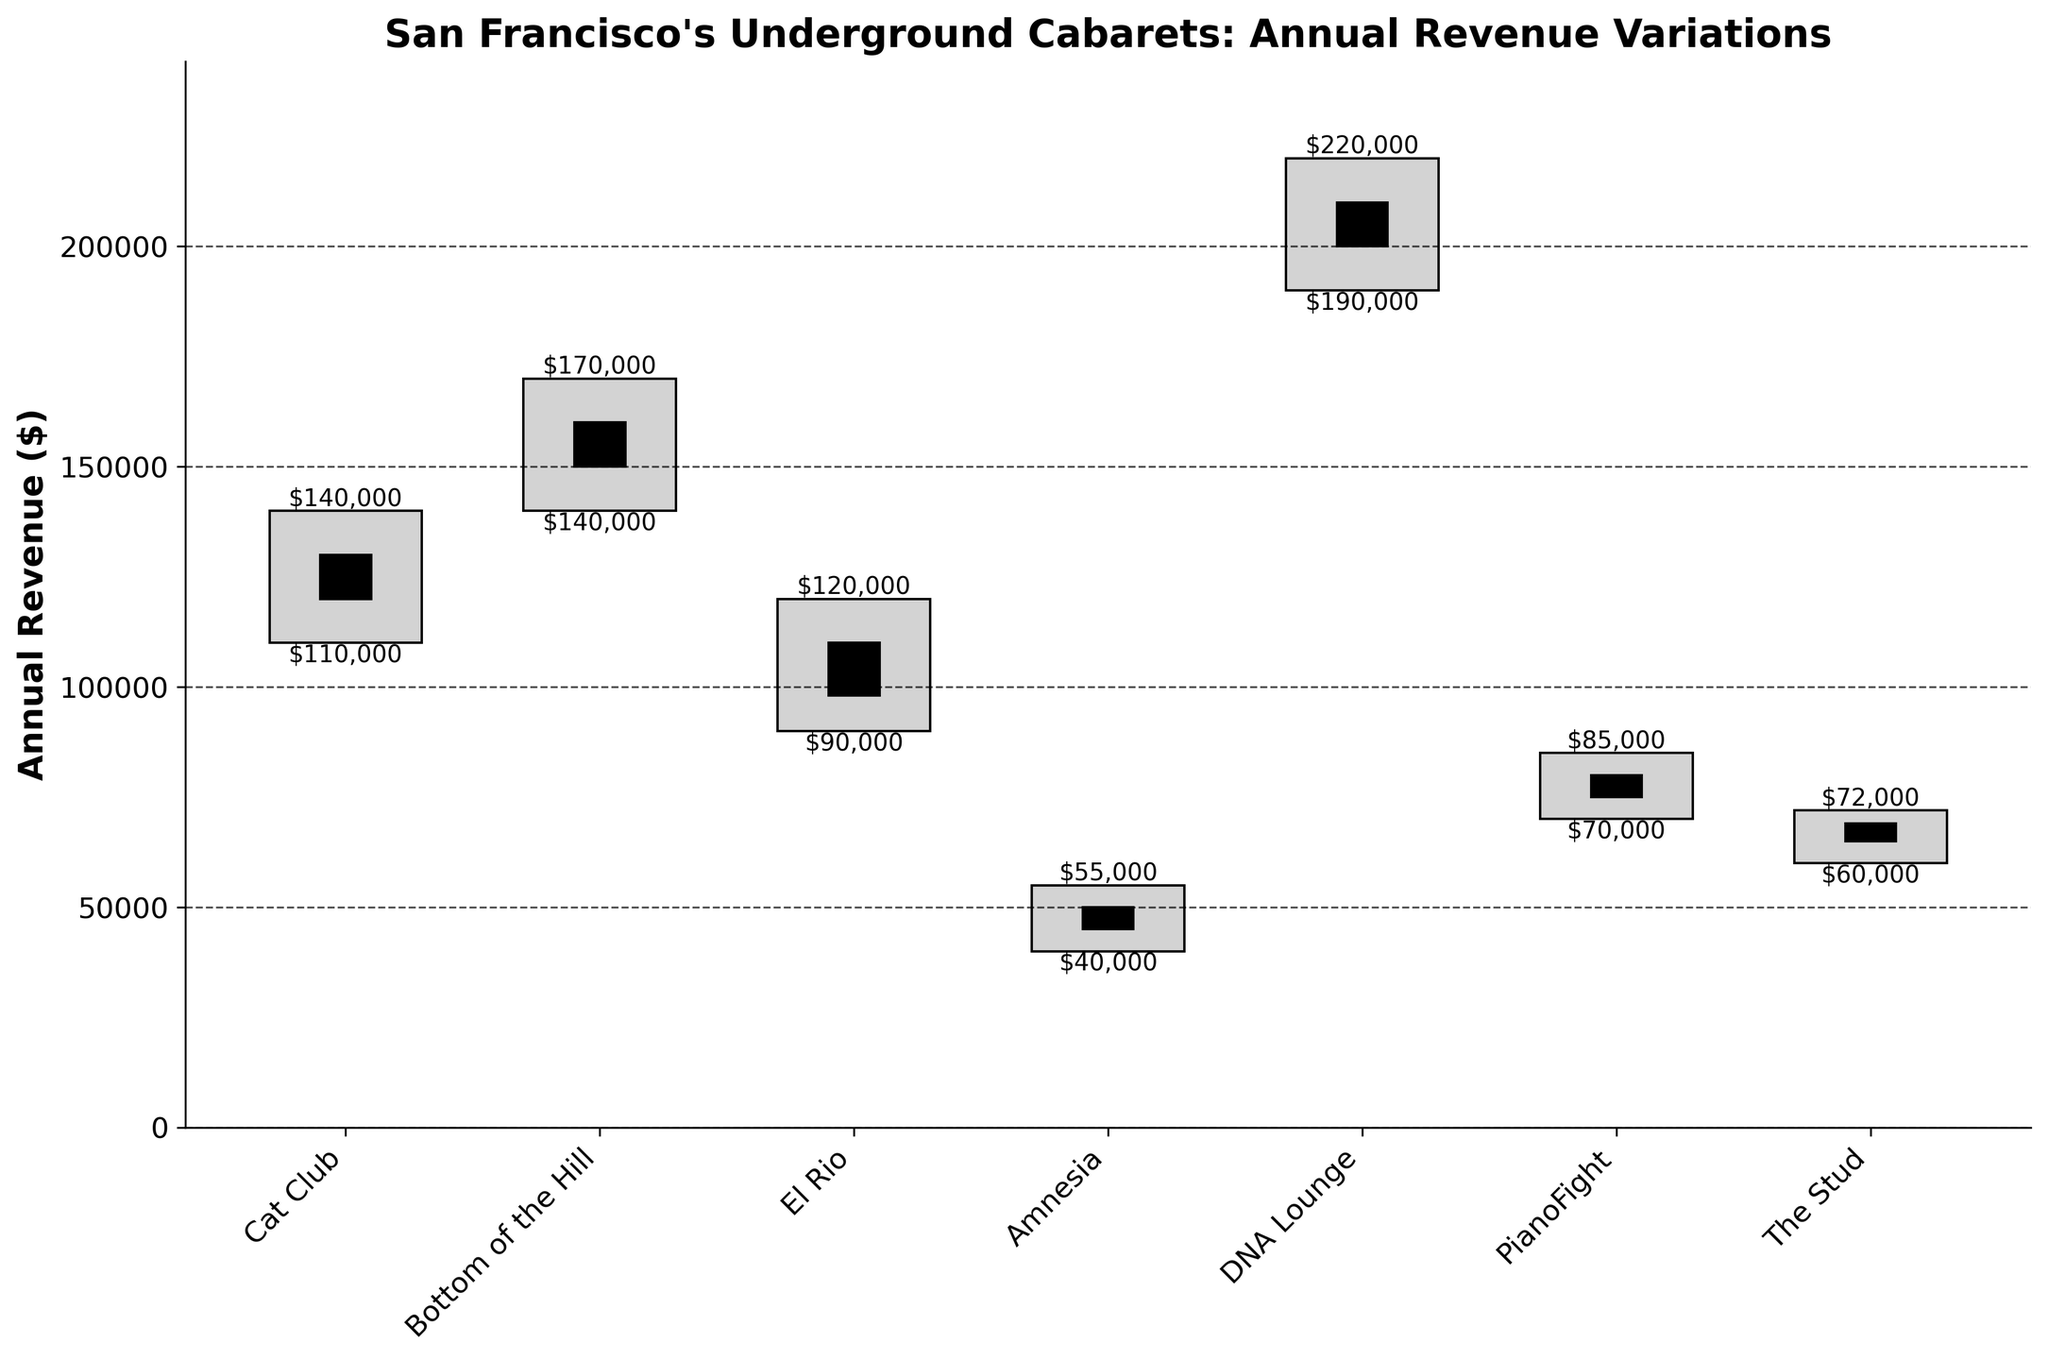What's the highest annual revenue recorded among all cabarets? The highest annual revenue is indicated by the highest point of the bar, which corresponds to the High values. Looking at the figure, DNA Lounge has the highest annual revenue with a High value of $220,000.
Answer: $220,000 Which cabaret has the smallest difference between its Opening and Closing revenues? The smallest difference between Opening and Closing values can be visualized by the height of the black bars. Amnesia has the smallest black bar, indicating the smallest revenue difference. The difference is $50,000 - $45,000 = $5,000.
Answer: Amnesia What's the title of the figure? The title of the figure is usually located at the top of the plot. It reads: "San Francisco's Underground Cabarets: Annual Revenue Variations".
Answer: San Francisco's Underground Cabarets: Annual Revenue Variations Compare the High values of Cat Club and Bottom of the Hill. Which one is higher? Comparing the heights of the grey bars with the High values, Bottom of the Hill’s High value ($170,000) is higher than Cat Club’s High value ($140,000).
Answer: Bottom of the Hill How many cabarets have their Low annual revenue below $100,000? By checking the Low values indicated at the bottom of each grey bar, three cabarets (El Rio, Amnesia, and The Stud) have their Low values below $100,000.
Answer: 3 What is the mean of the highest annual revenues of all cabarets? Sum the High values: $140,000 (Cat Club) + $170,000 (Bottom of the Hill) + $120,000 (El Rio) + $55,000 (Amnesia) + $220,000 (DNA Lounge) + $85,000 (PianoFight) + $72,000 (The Stud) = $862,000. Divide by the number of cabarets: $862,000 / 7 = $123,142.86.
Answer: $123,142.86 Which cabaret shows the largest variability in annual revenue? Variability is indicated by the difference between High and Low values, represented by the height of the entire grey bar. DNA Lounge has the greatest difference: $220,000 - $190,000 = $30,000.
Answer: DNA Lounge What is the median of the Closing revenues for all cabarets? List Closing values: 13,000 (Cat Club), 16,000 (Bottom of the Hill), 11,000 (El Rio), 50,000 (Amnesia), 21,000 (DNA Lounge), 80,000 (PianoFight), 69,000 (The Stud). Ordering these: $50,500, $11,00, $13,000, $16,000, $21,000, $69,000, $80,000. The middle value (median) is $16,000.
Answer: $16,000 